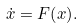<formula> <loc_0><loc_0><loc_500><loc_500>\dot { x } = { F } { \left ( { x } \right ) } .</formula> 